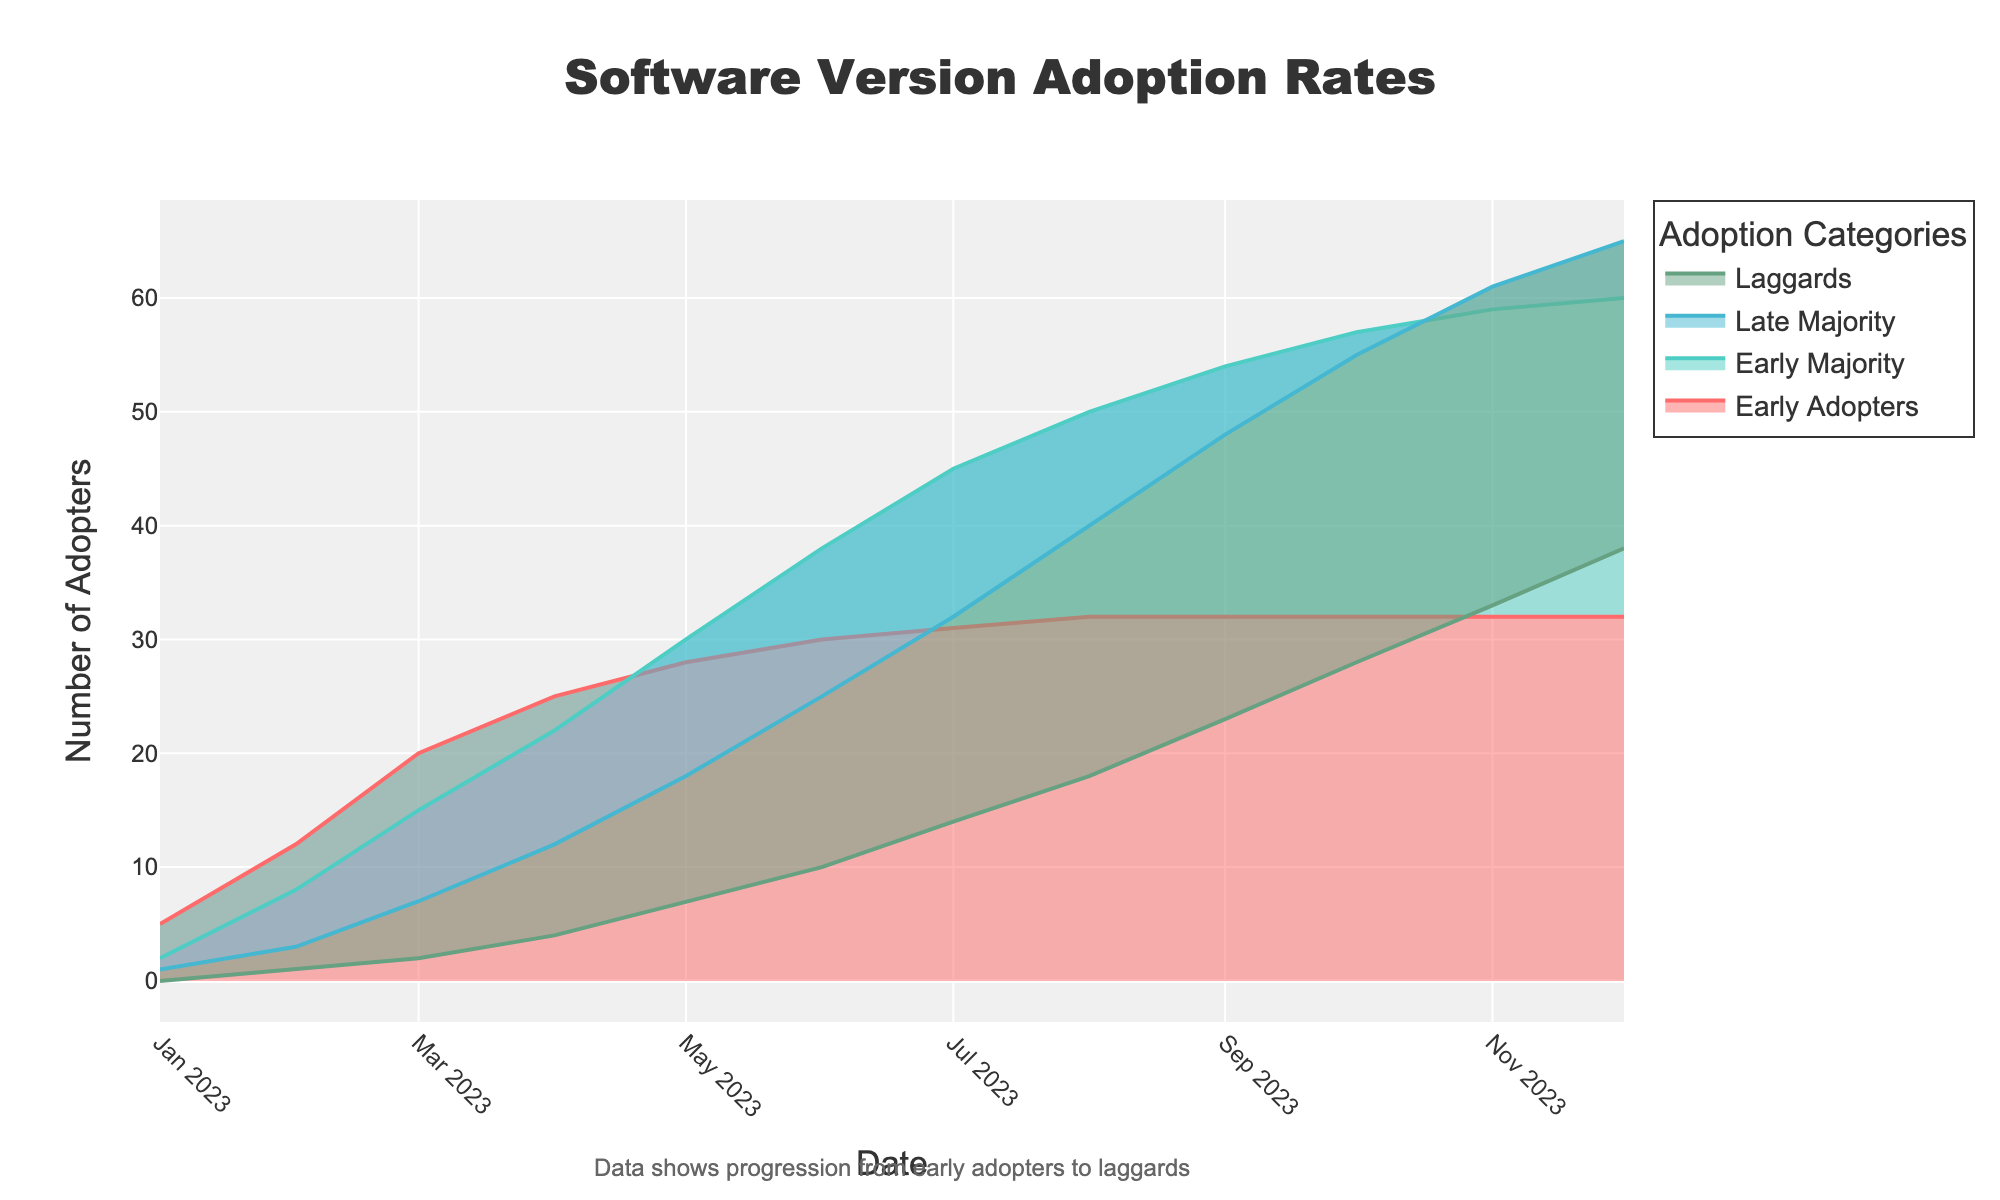What is the title of the fan chart? The title of the chart is typically displayed prominently at the top of the figure. It provides an overview of the data being shown.
Answer: Software Version Adoption Rates How many categories of adopters are shown in the chart? By looking at the legend and different colored areas on the chart, you can count the distinct categories.
Answer: Four On what date did the number of early adopters first reach 30? Look for the data point where the early adopters line reaches 30 on the x-axis representing dates.
Answer: 2023-06-01 Which month shows the highest number of laggards? Identify the peak point of the laggards category on the y-axis and cross-reference it with the date on the x-axis.
Answer: 2023-12-01 How many adopters does the early majority category have in April 2023? Find April 2023 on the x-axis and read the y-axis value for the early majority category.
Answer: 22 What trend can be observed for the early majority over time? Evaluate how the line for early majority moves from the start to the end date, focusing on the increase or decrease pattern.
Answer: The early majority steadily increases Compare the number of late adopters to early adopters in July 2023. Are there more late adopters or early adopters? Look at the y-values for both late adopters and early adopters in July 2023 and see which is higher.
Answer: More early adopters What is the combined total of early adopters, early majority, late majority, and laggards in May 2023? Sum the values of all four categories for May 2023. 28 (early adopters) + 30 (early majority) + 18 (late majority) + 7 (laggards) = 83.
Answer: 83 During which month does the number of late majority adopters surpass 40? Trace the late majority line and identify when it crosses the 40 mark on the y-axis.
Answer: August 2023 